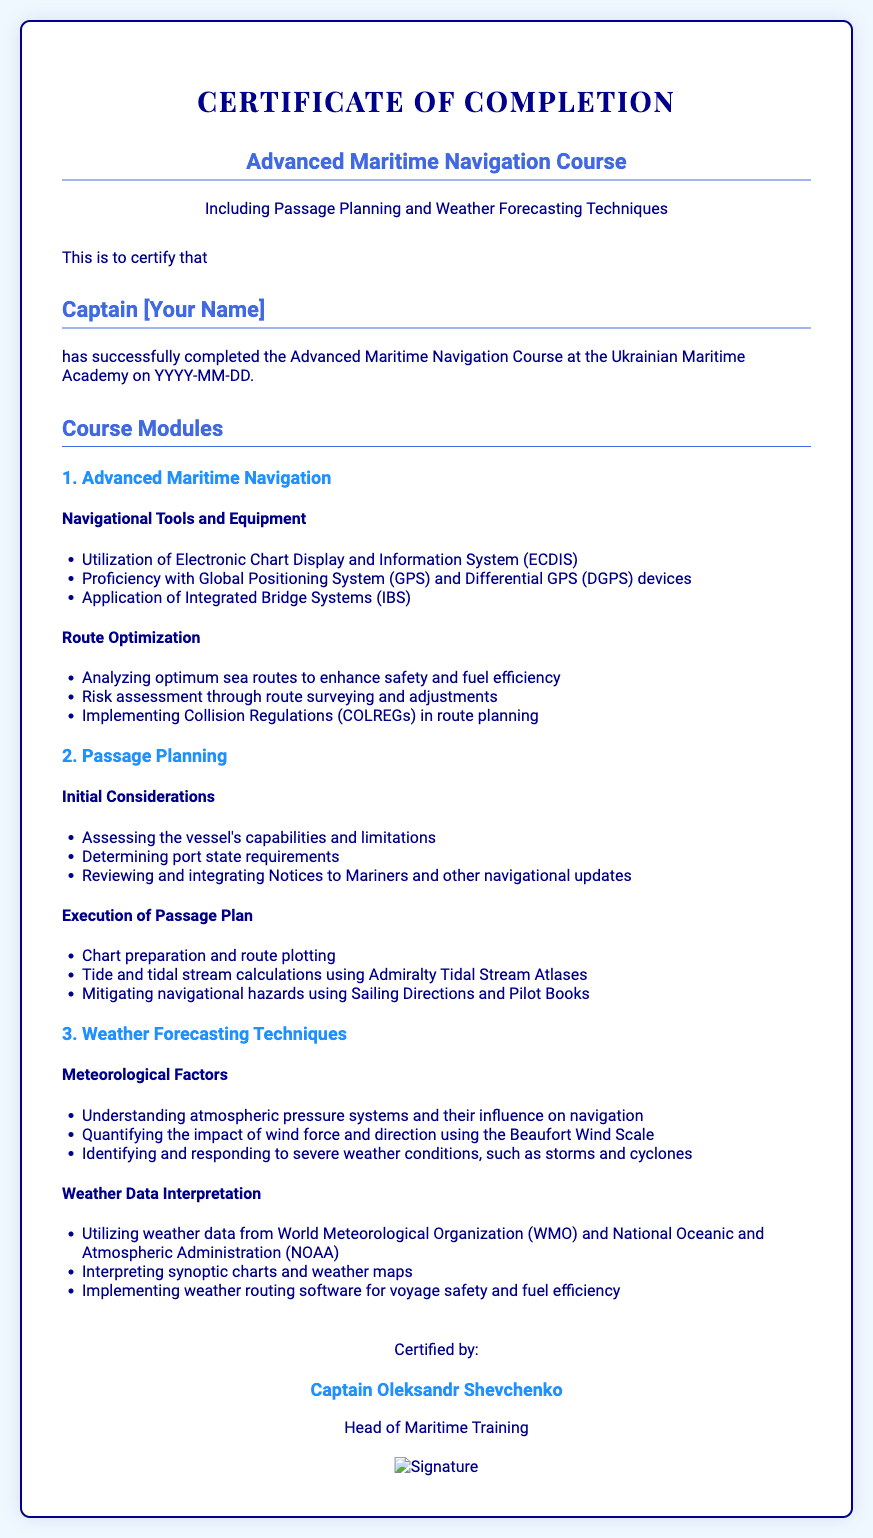what is the title of the course? The title of the course is stated clearly in the heading of the certificate.
Answer: Advanced Maritime Navigation Course who is the certificate issued to? The name of the individual to whom the certificate is issued is mentioned prominently on the certificate.
Answer: Captain [Your Name] when was the course completed? The completion date is indicated within the certificate, formatted as YYYY-MM-DD.
Answer: YYYY-MM-DD who certified the completion of the course? The person who certified the completion of the course is mentioned at the bottom of the certificate.
Answer: Captain Oleksandr Shevchenko what institution conducted the course? The name of the institution where the course took place is listed in the certificate text.
Answer: Ukrainian Maritime Academy how many modules are in the course? The number of modules is outlined in the section headings corresponding to each module.
Answer: 3 what is one topic covered under Weather Forecasting Techniques? Specific topics are listed under each module heading, summarizing the content taught.
Answer: Meteorological Factors what is an example of navigational equipment discussed in the course? The certificate lists examples of navigational tools used in the course content.
Answer: Electronic Chart Display and Information System (ECDIS) 